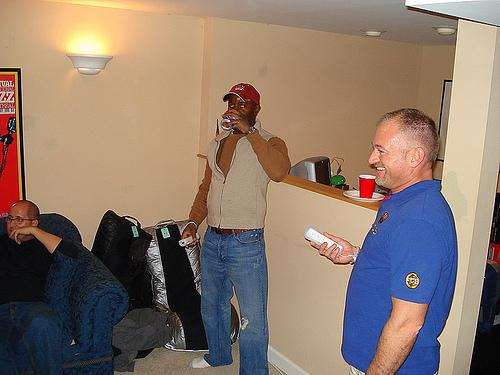What happen to the eyes of the man who is drinking? rolling 